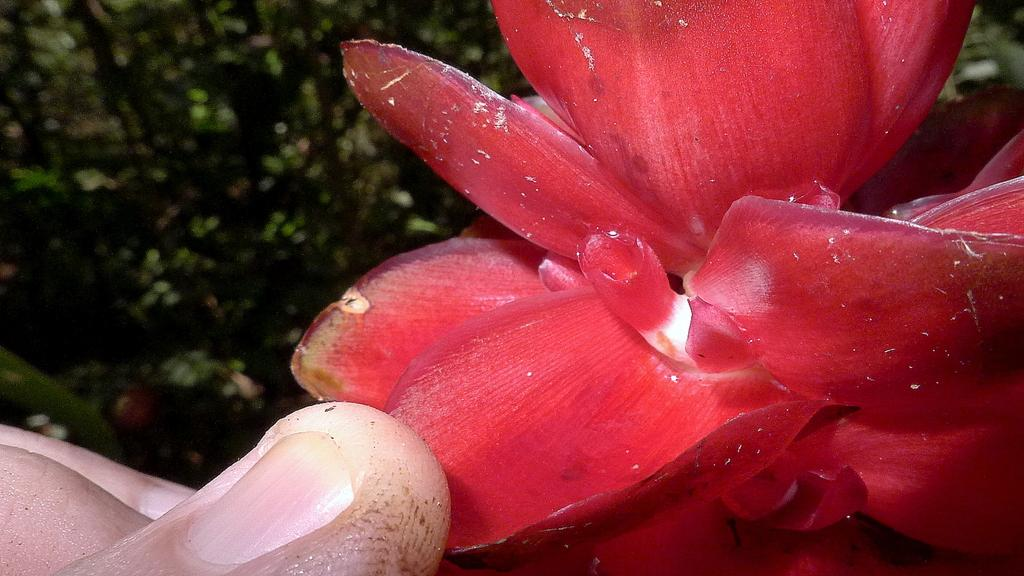What is the person's hand holding in the image? There is a person's hand holding a flower in the image. Can you describe the background of the image? The background of the image is blurred. How many snails can be seen crawling on the stamp in the image? There is no stamp or snails present in the image. 